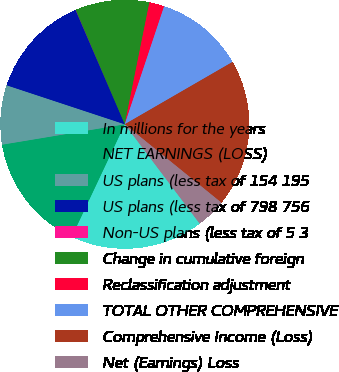<chart> <loc_0><loc_0><loc_500><loc_500><pie_chart><fcel>In millions for the years<fcel>NET EARNINGS (LOSS)<fcel>US plans (less tax of 154 195<fcel>US plans (less tax of 798 756<fcel>Non-US plans (less tax of 5 3<fcel>Change in cumulative foreign<fcel>Reclassification adjustment<fcel>TOTAL OTHER COMPREHENSIVE<fcel>Comprehensive Income (Loss)<fcel>Net (Earnings) Loss<nl><fcel>17.29%<fcel>15.37%<fcel>7.7%<fcel>13.45%<fcel>0.03%<fcel>9.62%<fcel>1.95%<fcel>11.53%<fcel>19.2%<fcel>3.87%<nl></chart> 